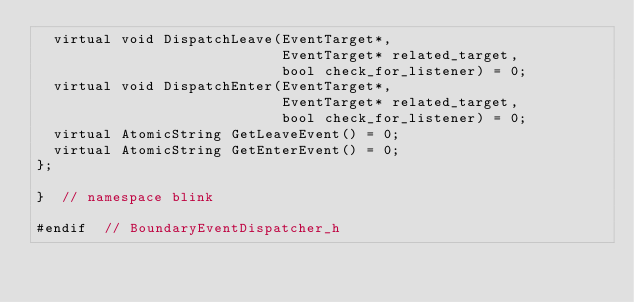Convert code to text. <code><loc_0><loc_0><loc_500><loc_500><_C_>  virtual void DispatchLeave(EventTarget*,
                             EventTarget* related_target,
                             bool check_for_listener) = 0;
  virtual void DispatchEnter(EventTarget*,
                             EventTarget* related_target,
                             bool check_for_listener) = 0;
  virtual AtomicString GetLeaveEvent() = 0;
  virtual AtomicString GetEnterEvent() = 0;
};

}  // namespace blink

#endif  // BoundaryEventDispatcher_h
</code> 